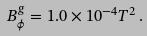<formula> <loc_0><loc_0><loc_500><loc_500>B ^ { g } _ { \phi } = 1 . 0 \times 1 0 ^ { - 4 } T ^ { 2 } \, .</formula> 